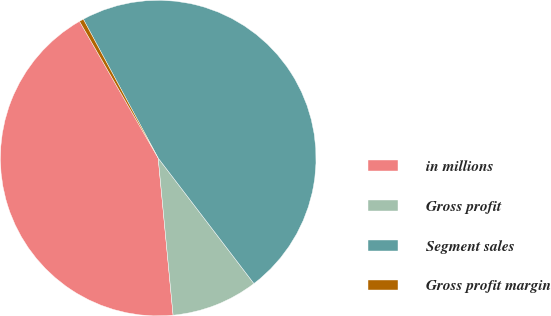Convert chart to OTSL. <chart><loc_0><loc_0><loc_500><loc_500><pie_chart><fcel>in millions<fcel>Gross profit<fcel>Segment sales<fcel>Gross profit margin<nl><fcel>43.2%<fcel>8.87%<fcel>47.5%<fcel>0.44%<nl></chart> 